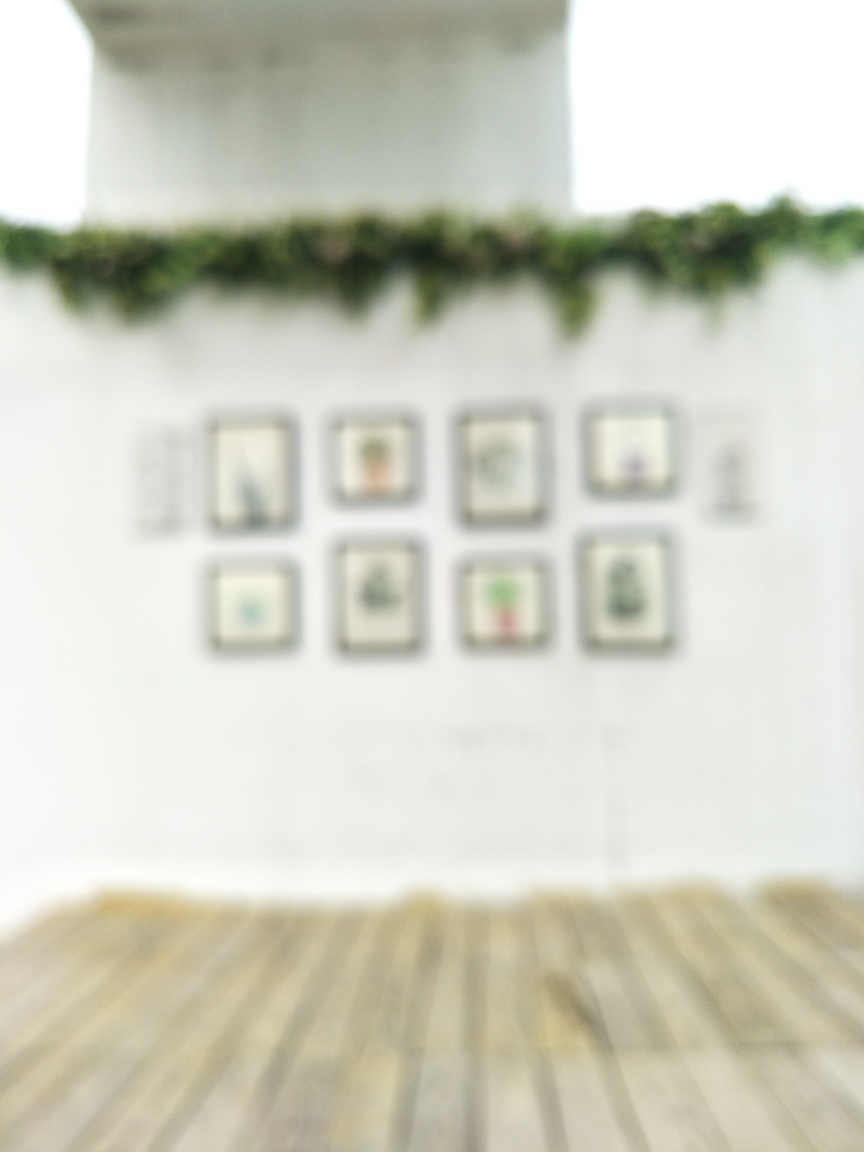Does the image have poor quality?
A. Yes
B. No
Answer with the option's letter from the given choices directly.
 A. 